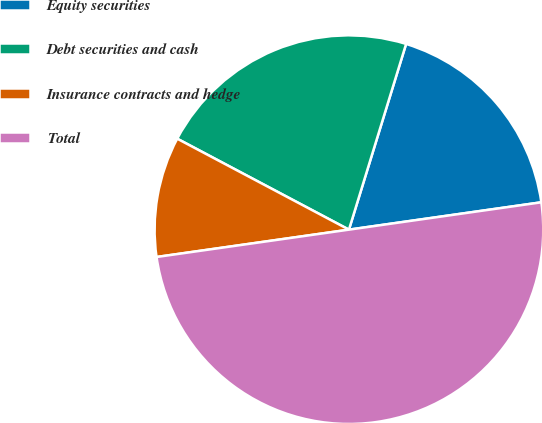Convert chart to OTSL. <chart><loc_0><loc_0><loc_500><loc_500><pie_chart><fcel>Equity securities<fcel>Debt securities and cash<fcel>Insurance contracts and hedge<fcel>Total<nl><fcel>18.0%<fcel>22.0%<fcel>10.0%<fcel>50.0%<nl></chart> 